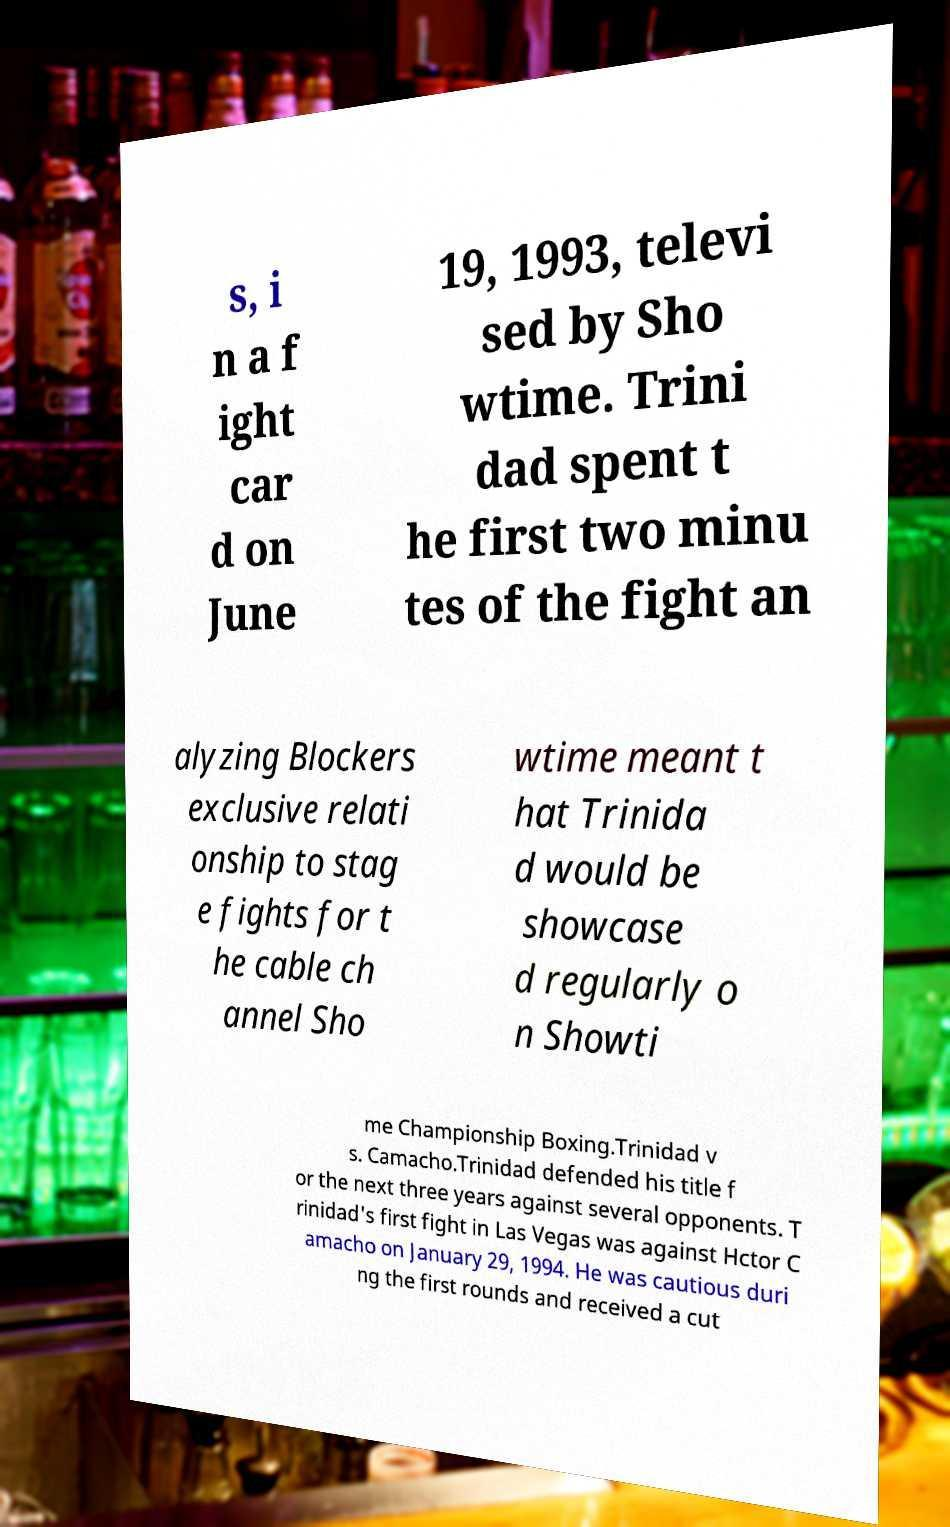Could you extract and type out the text from this image? s, i n a f ight car d on June 19, 1993, televi sed by Sho wtime. Trini dad spent t he first two minu tes of the fight an alyzing Blockers exclusive relati onship to stag e fights for t he cable ch annel Sho wtime meant t hat Trinida d would be showcase d regularly o n Showti me Championship Boxing.Trinidad v s. Camacho.Trinidad defended his title f or the next three years against several opponents. T rinidad's first fight in Las Vegas was against Hctor C amacho on January 29, 1994. He was cautious duri ng the first rounds and received a cut 